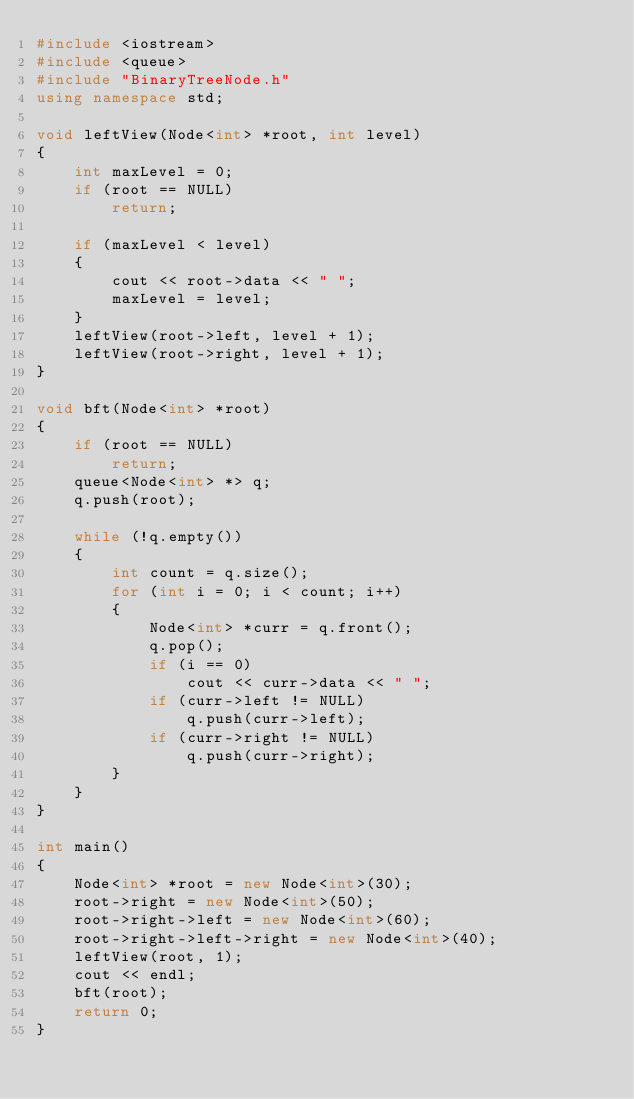Convert code to text. <code><loc_0><loc_0><loc_500><loc_500><_C++_>#include <iostream>
#include <queue>
#include "BinaryTreeNode.h"
using namespace std;

void leftView(Node<int> *root, int level)
{
    int maxLevel = 0;
    if (root == NULL)
        return;

    if (maxLevel < level)
    {
        cout << root->data << " ";
        maxLevel = level;
    }
    leftView(root->left, level + 1);
    leftView(root->right, level + 1);
}

void bft(Node<int> *root)
{
    if (root == NULL)
        return;
    queue<Node<int> *> q;
    q.push(root);

    while (!q.empty())
    {
        int count = q.size();
        for (int i = 0; i < count; i++)
        {
            Node<int> *curr = q.front();
            q.pop();
            if (i == 0)
                cout << curr->data << " ";
            if (curr->left != NULL)
                q.push(curr->left);
            if (curr->right != NULL)
                q.push(curr->right);
        }
    }
}

int main()
{
    Node<int> *root = new Node<int>(30);
    root->right = new Node<int>(50);
    root->right->left = new Node<int>(60);
    root->right->left->right = new Node<int>(40);
    leftView(root, 1);
    cout << endl;
    bft(root);
    return 0;
}</code> 